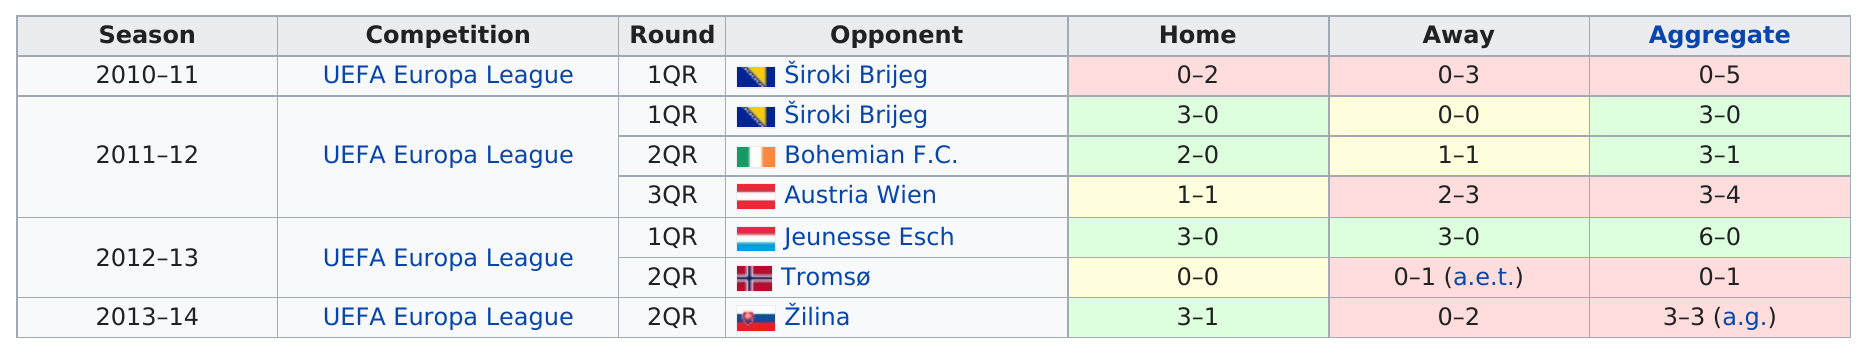Draw attention to some important aspects in this diagram. In this chart, Žilina was the last opponent facing the team in the specified competition. In 2010, Široki Brijeg scored at least three goals. In the only year they went 1-1 at home, 2011-12, occurred. From the years 2011 to 2014, the team had at least one home win in each season In the 2010 season, Široki Brijeg won. 